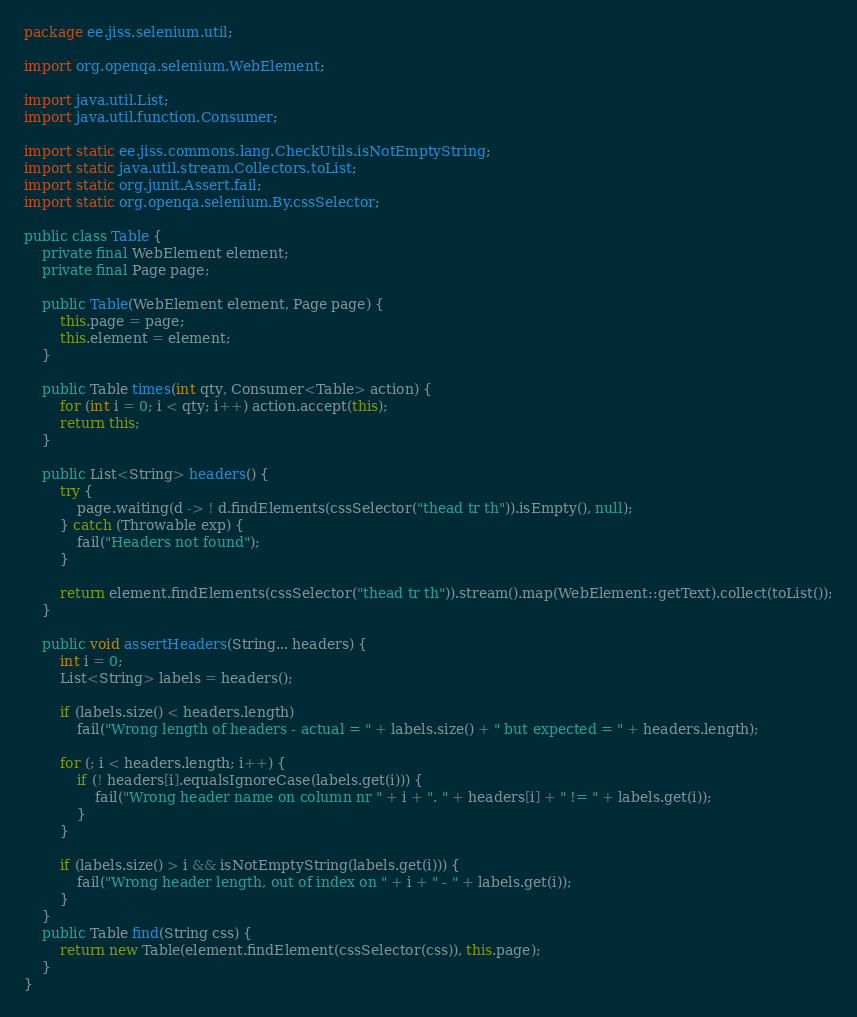Convert code to text. <code><loc_0><loc_0><loc_500><loc_500><_Java_>package ee.jiss.selenium.util;

import org.openqa.selenium.WebElement;

import java.util.List;
import java.util.function.Consumer;

import static ee.jiss.commons.lang.CheckUtils.isNotEmptyString;
import static java.util.stream.Collectors.toList;
import static org.junit.Assert.fail;
import static org.openqa.selenium.By.cssSelector;

public class Table {
    private final WebElement element;
    private final Page page;

    public Table(WebElement element, Page page) {
        this.page = page;
        this.element = element;
    }

    public Table times(int qty, Consumer<Table> action) {
        for (int i = 0; i < qty; i++) action.accept(this);
        return this;
    }

    public List<String> headers() {
        try {
            page.waiting(d -> ! d.findElements(cssSelector("thead tr th")).isEmpty(), null);
        } catch (Throwable exp) {
            fail("Headers not found");
        }

        return element.findElements(cssSelector("thead tr th")).stream().map(WebElement::getText).collect(toList());
    }

    public void assertHeaders(String... headers) {
        int i = 0;
        List<String> labels = headers();

        if (labels.size() < headers.length)
            fail("Wrong length of headers - actual = " + labels.size() + " but expected = " + headers.length);

        for (; i < headers.length; i++) {
            if (! headers[i].equalsIgnoreCase(labels.get(i))) {
                fail("Wrong header name on column nr " + i + ". " + headers[i] + " != " + labels.get(i));
            }
        }

        if (labels.size() > i && isNotEmptyString(labels.get(i))) {
            fail("Wrong header length, out of index on " + i + " - " + labels.get(i));
        }
    }
    public Table find(String css) {
        return new Table(element.findElement(cssSelector(css)), this.page);
    }
}
</code> 